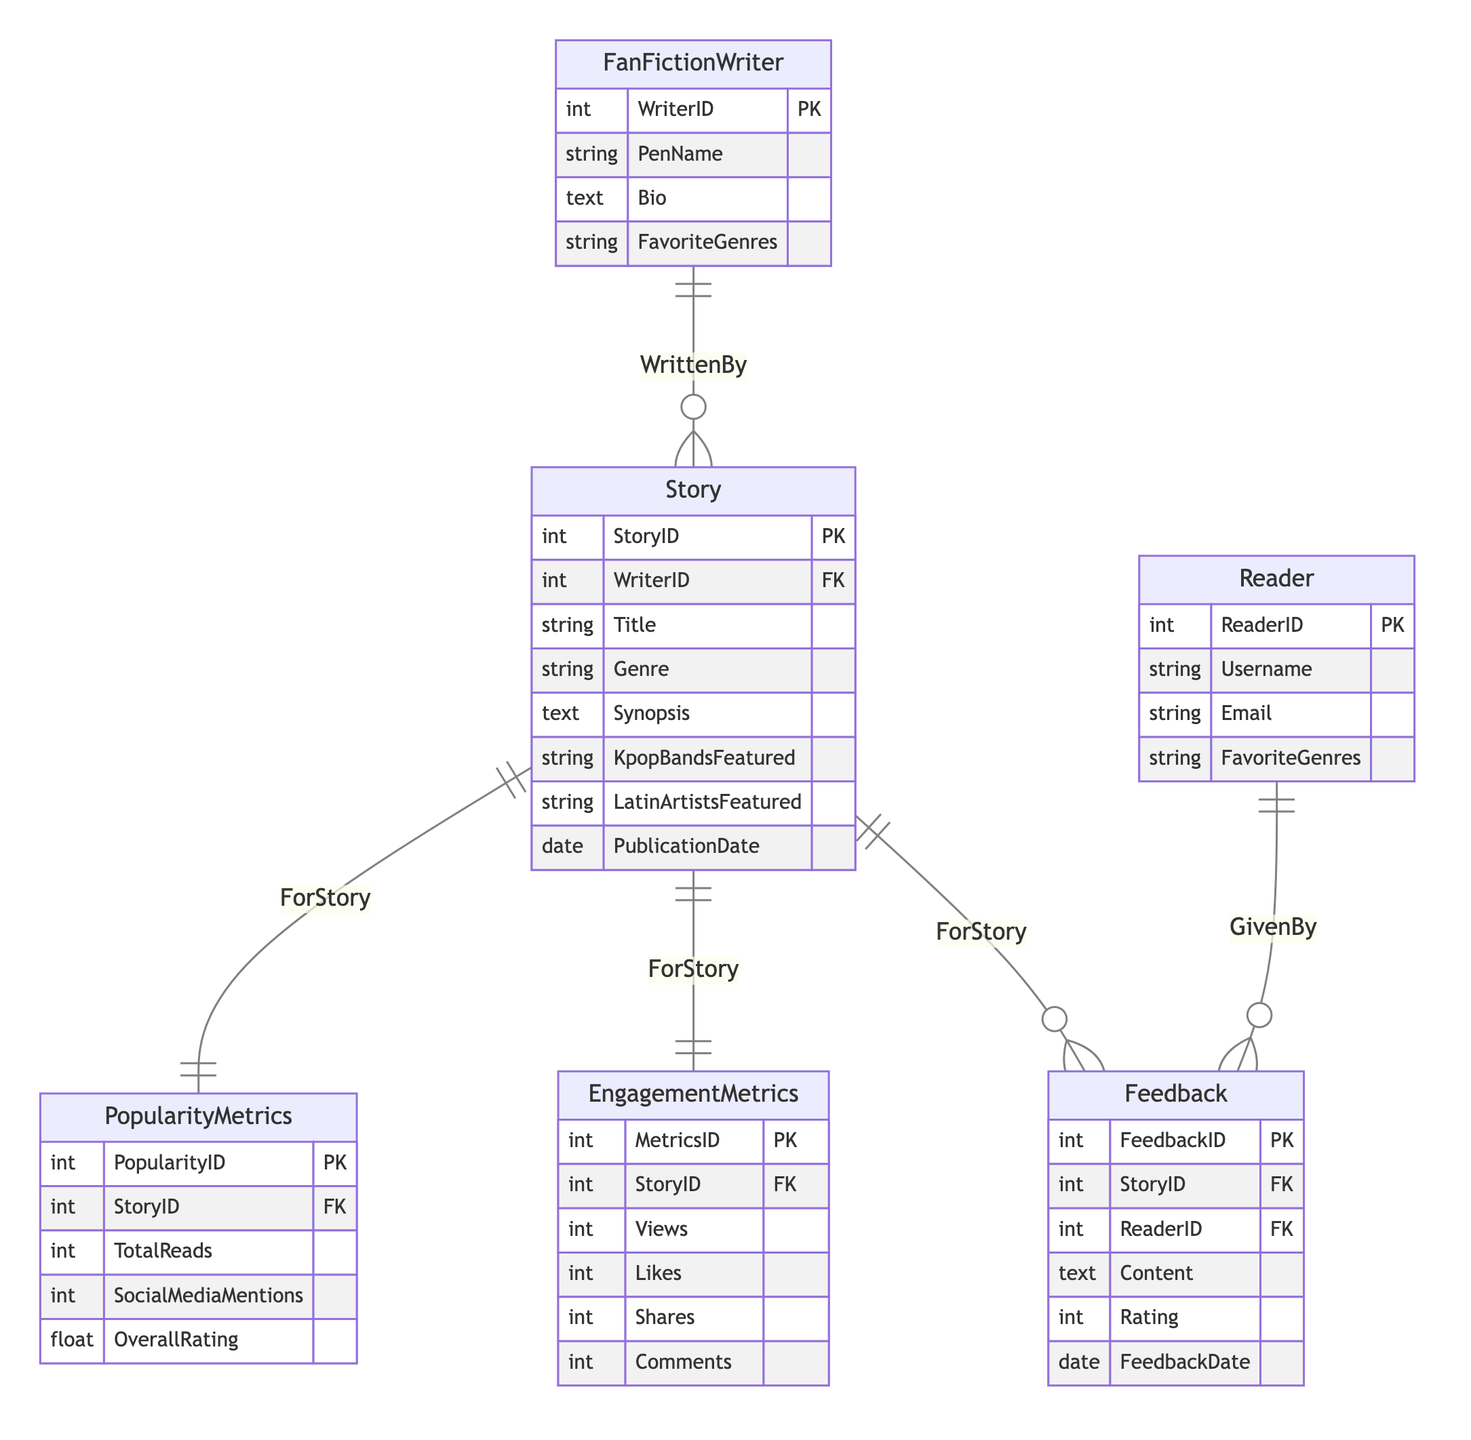What is the primary key of the Story entity? The primary key of the Story entity is StoryID, which is indicated as the unique identifier for stories.
Answer: StoryID How many entities are defined in the diagram? The diagram includes six entities: FanFictionWriter, Story, Reader, Feedback, EngagementMetrics, and PopularityMetrics.
Answer: Six What type of relationship exists between Story and Feedback? The relationship between Story and Feedback is Many-to-One, indicating that each story can receive multiple pieces of feedback from readers.
Answer: Many-to-One What are the attributes of the Feedback entity? The attributes of the Feedback entity include FeedbackID, StoryID, ReaderID, Content, Rating, and FeedbackDate, which provide information on feedback given by readers on stories.
Answer: FeedbackID, StoryID, ReaderID, Content, Rating, FeedbackDate Which entity has a One-to-One relationship with EngagementMetrics? The EngagementMetrics entity has a One-to-One relationship with the Story entity, meaning each story has only one set of engagement metrics associated with it.
Answer: Story How many foreign keys does the Feedback entity have? The Feedback entity has two foreign keys: StoryID and ReaderID, which link feedback to specific stories and readers, respectively.
Answer: Two What is the main purpose of the PopularityMetrics entity? The main purpose of the PopularityMetrics entity is to track metrics related to a story's popularity, such as TotalReads and SocialMediaMentions, indicating how well a story is received.
Answer: Track popularity metrics Which attribute in the FanFictionWriter entity indicates their interests? The FavoriteGenres attribute in the FanFictionWriter entity indicates the preferred genres of the writer, providing insight into their interests and writing style.
Answer: FavoriteGenres What type of relationship exists between Reader and Feedback? The relationship between Reader and Feedback is Many-to-One, meaning that multiple feedback entries can be associated with one reader.
Answer: Many-to-One 